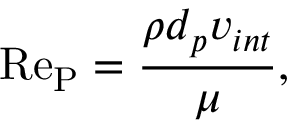Convert formula to latex. <formula><loc_0><loc_0><loc_500><loc_500>\mathrm { R e } _ { P } = \frac { \rho d _ { p } v _ { i n t } } { \mu } ,</formula> 